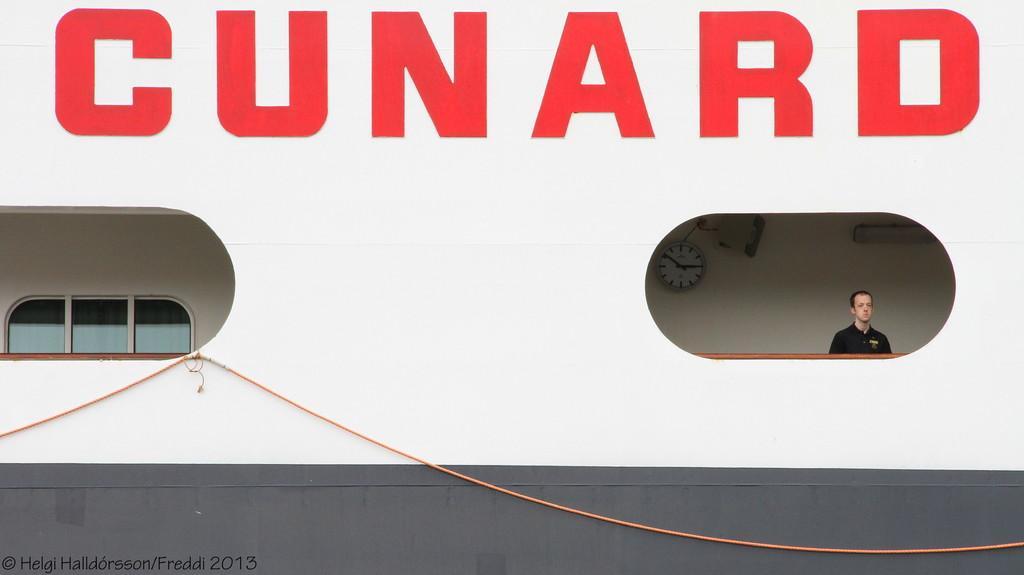Could you give a brief overview of what you see in this image? In this image, I can see windows, clock and a person is standing maybe in a boat and I can see a rope. At the top, I can see a text. This picture might be taken in a day. 